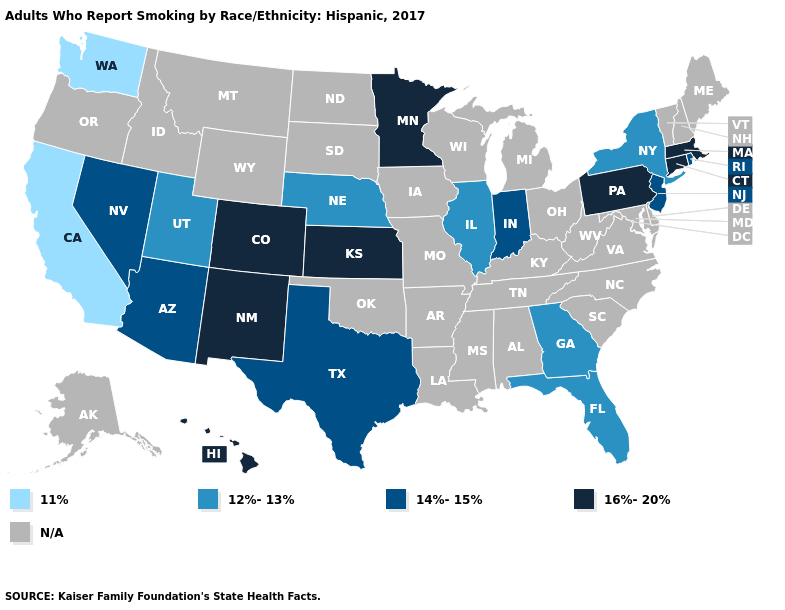What is the value of Illinois?
Write a very short answer. 12%-13%. Which states hav the highest value in the MidWest?
Concise answer only. Kansas, Minnesota. Does New York have the lowest value in the USA?
Answer briefly. No. What is the value of Indiana?
Quick response, please. 14%-15%. What is the value of Mississippi?
Quick response, please. N/A. What is the lowest value in the USA?
Write a very short answer. 11%. Is the legend a continuous bar?
Be succinct. No. Does the first symbol in the legend represent the smallest category?
Write a very short answer. Yes. Name the states that have a value in the range 12%-13%?
Write a very short answer. Florida, Georgia, Illinois, Nebraska, New York, Utah. Name the states that have a value in the range 16%-20%?
Give a very brief answer. Colorado, Connecticut, Hawaii, Kansas, Massachusetts, Minnesota, New Mexico, Pennsylvania. Among the states that border Kansas , which have the lowest value?
Concise answer only. Nebraska. Which states have the lowest value in the Northeast?
Be succinct. New York. How many symbols are there in the legend?
Keep it brief. 5. 